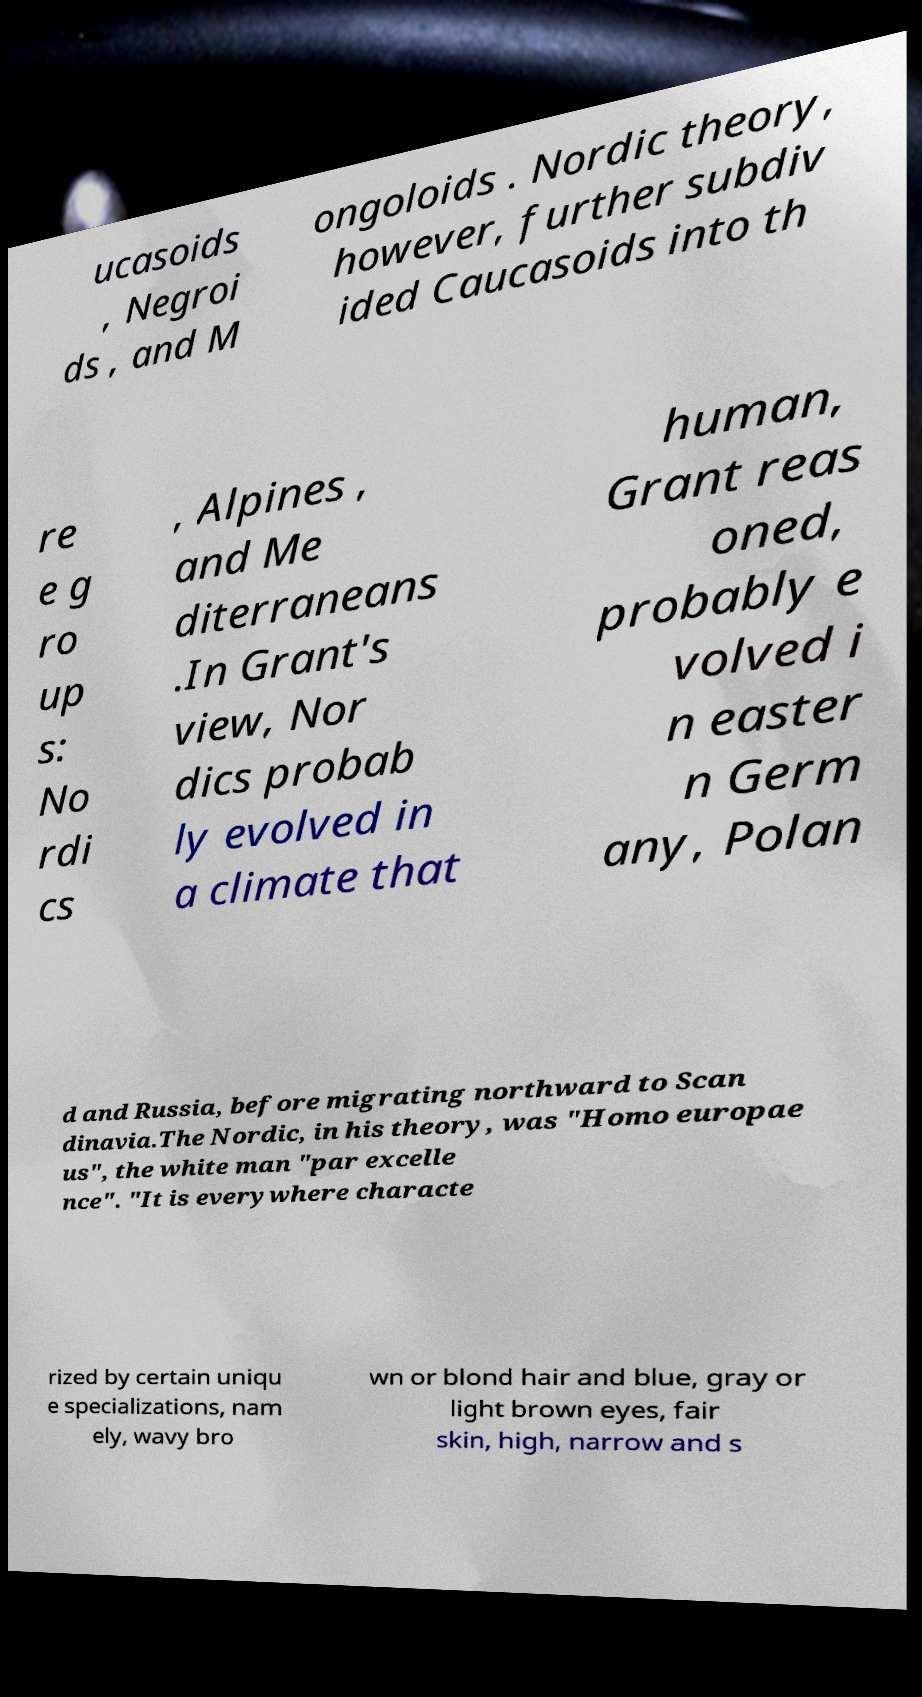For documentation purposes, I need the text within this image transcribed. Could you provide that? ucasoids , Negroi ds , and M ongoloids . Nordic theory, however, further subdiv ided Caucasoids into th re e g ro up s: No rdi cs , Alpines , and Me diterraneans .In Grant's view, Nor dics probab ly evolved in a climate that human, Grant reas oned, probably e volved i n easter n Germ any, Polan d and Russia, before migrating northward to Scan dinavia.The Nordic, in his theory, was "Homo europae us", the white man "par excelle nce". "It is everywhere characte rized by certain uniqu e specializations, nam ely, wavy bro wn or blond hair and blue, gray or light brown eyes, fair skin, high, narrow and s 